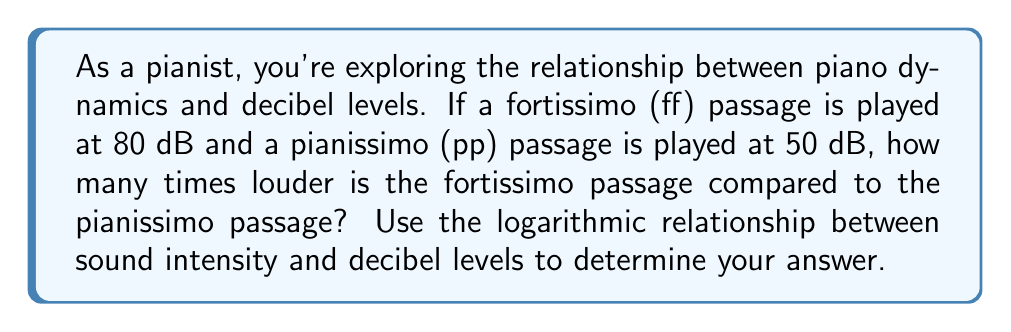Can you solve this math problem? Let's approach this step-by-step:

1) The relationship between decibel level (dB) and sound intensity (I) is given by the equation:
   $$ dB = 10 \log_{10}\left(\frac{I}{I_0}\right) $$
   where $I_0$ is a reference intensity.

2) Let $I_{ff}$ be the intensity of the fortissimo passage and $I_{pp}$ be the intensity of the pianissimo passage.

3) For the fortissimo passage (80 dB):
   $$ 80 = 10 \log_{10}\left(\frac{I_{ff}}{I_0}\right) $$

4) For the pianissimo passage (50 dB):
   $$ 50 = 10 \log_{10}\left(\frac{I_{pp}}{I_0}\right) $$

5) To find how many times louder ff is compared to pp, we need to calculate $\frac{I_{ff}}{I_{pp}}$.

6) From step 3:
   $$ \frac{I_{ff}}{I_0} = 10^8 $$

7) From step 4:
   $$ \frac{I_{pp}}{I_0} = 10^5 $$

8) Dividing these ratios:
   $$ \frac{I_{ff}}{I_{pp}} = \frac{10^8}{10^5} = 10^3 = 1000 $$

Therefore, the fortissimo passage is 1000 times louder than the pianissimo passage.
Answer: 1000 times louder 